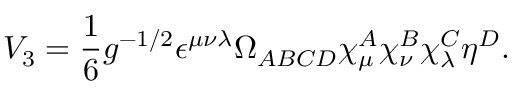Convert formula to latex. <formula><loc_0><loc_0><loc_500><loc_500>V _ { 3 } = \frac { 1 } { 6 } g ^ { - 1 / 2 } \epsilon ^ { \mu \nu \lambda } \Omega _ { A B C D } \chi _ { \mu } ^ { A } \chi _ { \nu } ^ { B } \chi _ { \lambda } ^ { C } \eta ^ { D } .</formula> 